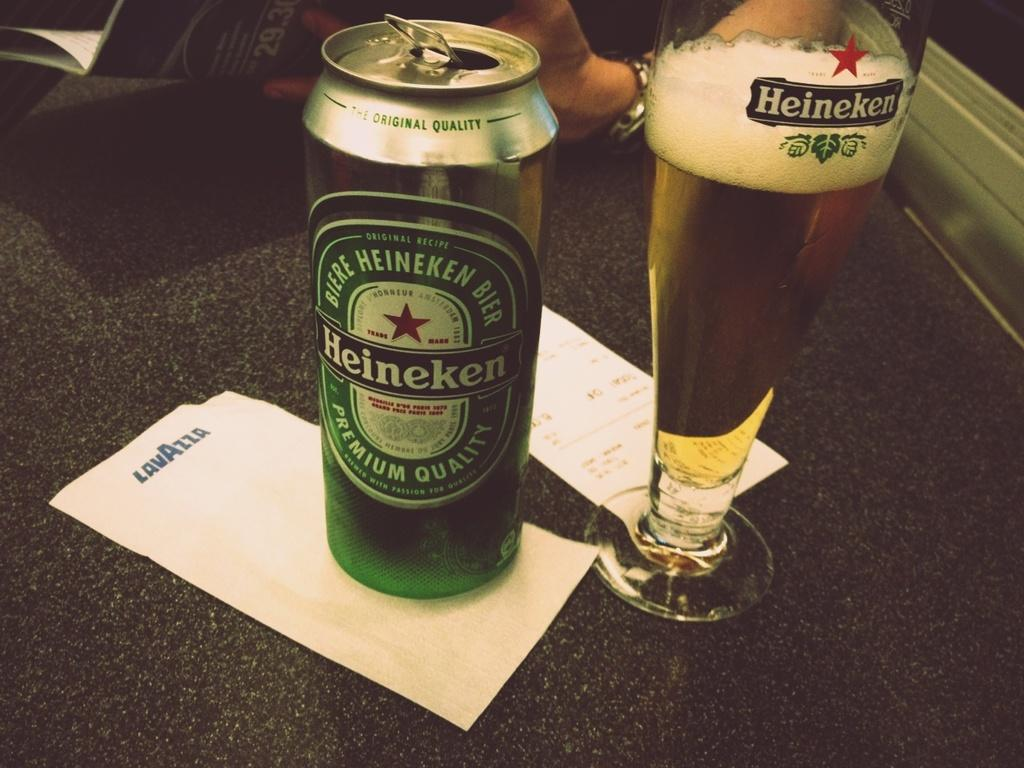<image>
Create a compact narrative representing the image presented. A tall heineken can next to a tall heineken glass 